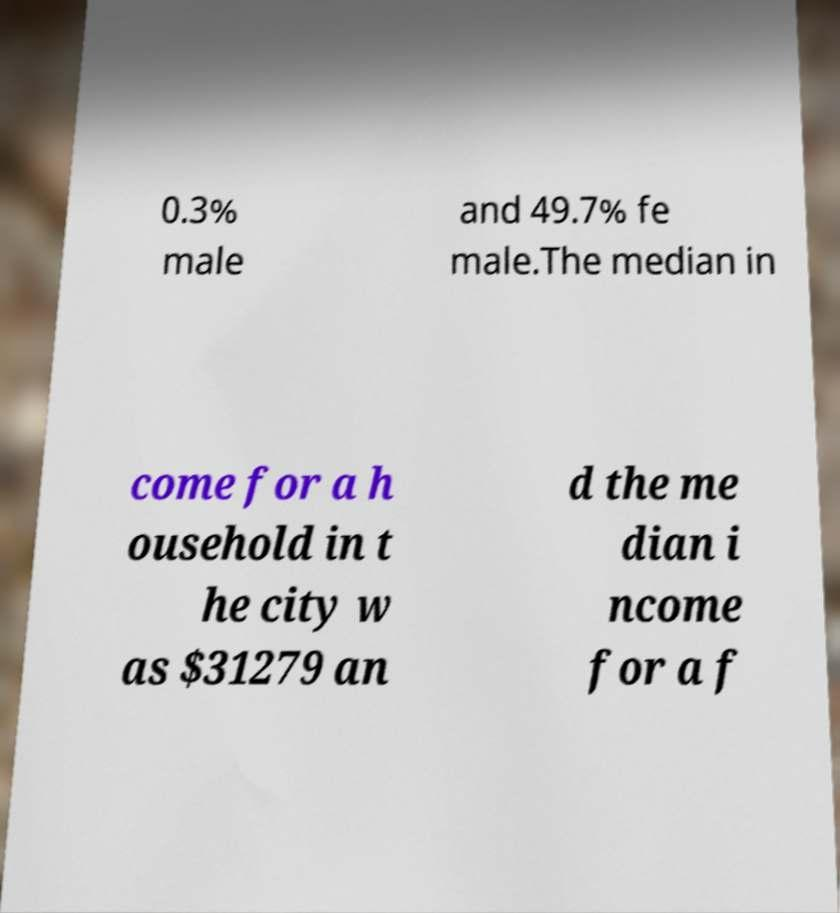Can you accurately transcribe the text from the provided image for me? 0.3% male and 49.7% fe male.The median in come for a h ousehold in t he city w as $31279 an d the me dian i ncome for a f 